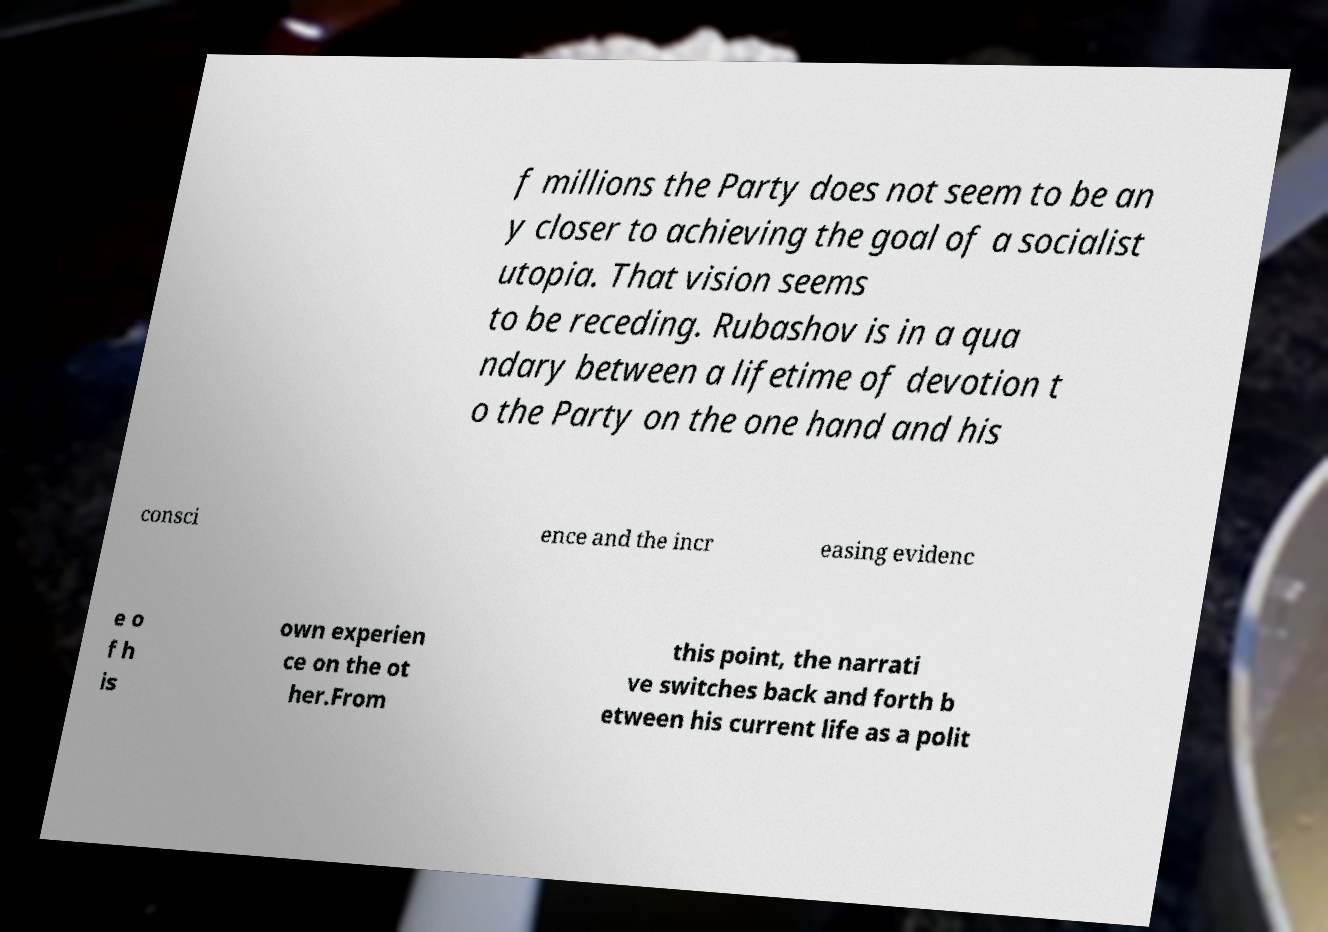What messages or text are displayed in this image? I need them in a readable, typed format. f millions the Party does not seem to be an y closer to achieving the goal of a socialist utopia. That vision seems to be receding. Rubashov is in a qua ndary between a lifetime of devotion t o the Party on the one hand and his consci ence and the incr easing evidenc e o f h is own experien ce on the ot her.From this point, the narrati ve switches back and forth b etween his current life as a polit 